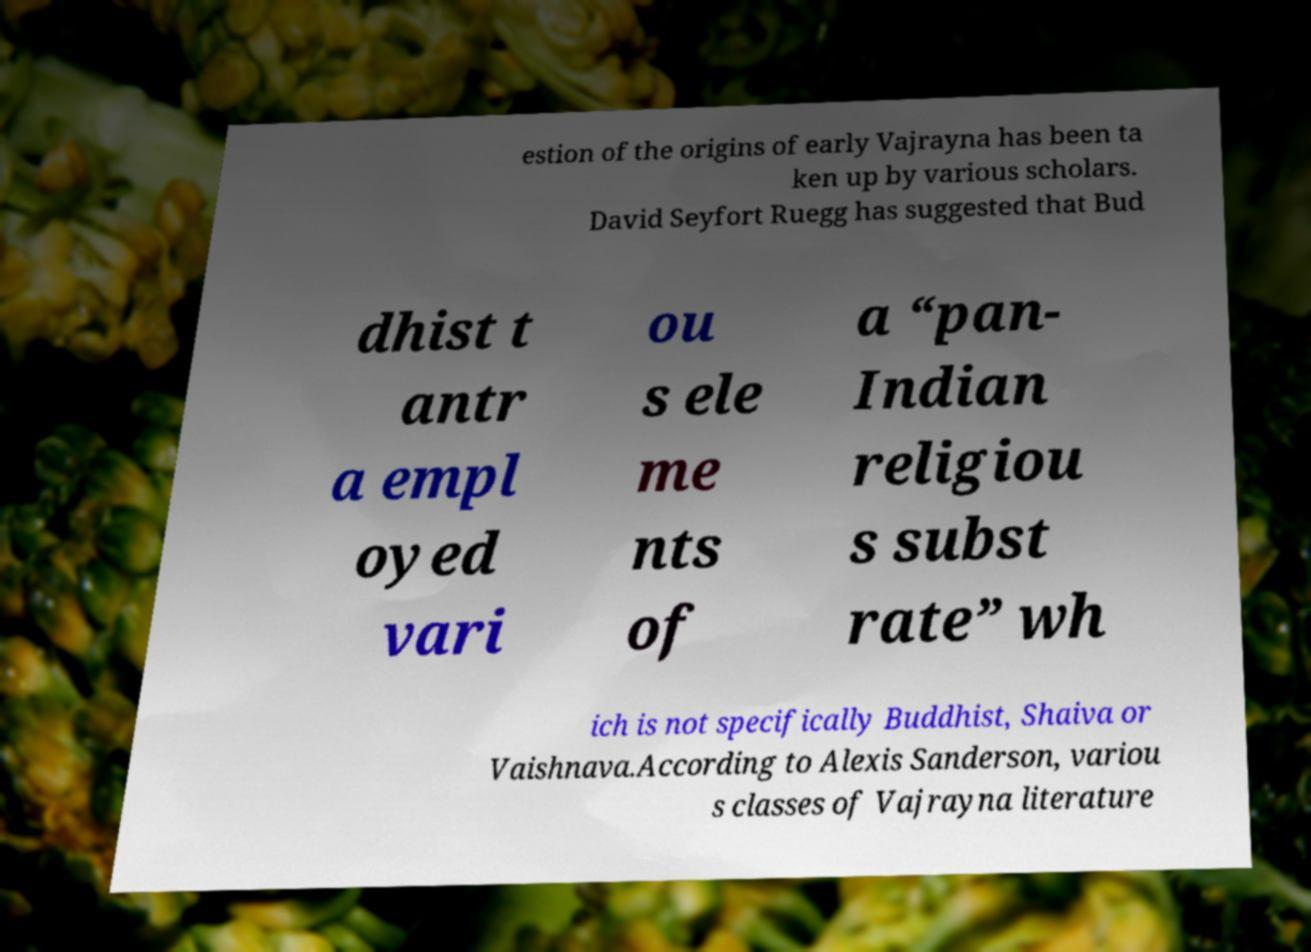What messages or text are displayed in this image? I need them in a readable, typed format. estion of the origins of early Vajrayna has been ta ken up by various scholars. David Seyfort Ruegg has suggested that Bud dhist t antr a empl oyed vari ou s ele me nts of a “pan- Indian religiou s subst rate” wh ich is not specifically Buddhist, Shaiva or Vaishnava.According to Alexis Sanderson, variou s classes of Vajrayna literature 